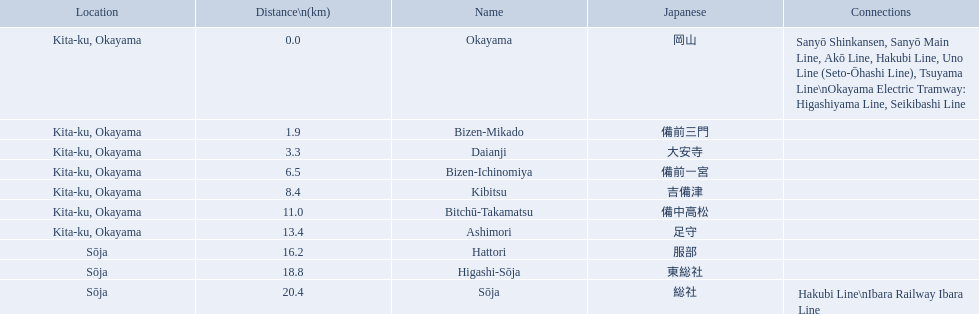What are all of the train names? Okayama, Bizen-Mikado, Daianji, Bizen-Ichinomiya, Kibitsu, Bitchū-Takamatsu, Ashimori, Hattori, Higashi-Sōja, Sōja. What is the distance for each? 0.0, 1.9, 3.3, 6.5, 8.4, 11.0, 13.4, 16.2, 18.8, 20.4. I'm looking to parse the entire table for insights. Could you assist me with that? {'header': ['Location', 'Distance\\n(km)', 'Name', 'Japanese', 'Connections'], 'rows': [['Kita-ku, Okayama', '0.0', 'Okayama', '岡山', 'Sanyō Shinkansen, Sanyō Main Line, Akō Line, Hakubi Line, Uno Line (Seto-Ōhashi Line), Tsuyama Line\\nOkayama Electric Tramway: Higashiyama Line, Seikibashi Line'], ['Kita-ku, Okayama', '1.9', 'Bizen-Mikado', '備前三門', ''], ['Kita-ku, Okayama', '3.3', 'Daianji', '大安寺', ''], ['Kita-ku, Okayama', '6.5', 'Bizen-Ichinomiya', '備前一宮', ''], ['Kita-ku, Okayama', '8.4', 'Kibitsu', '吉備津', ''], ['Kita-ku, Okayama', '11.0', 'Bitchū-Takamatsu', '備中高松', ''], ['Kita-ku, Okayama', '13.4', 'Ashimori', '足守', ''], ['Sōja', '16.2', 'Hattori', '服部', ''], ['Sōja', '18.8', 'Higashi-Sōja', '東総社', ''], ['Sōja', '20.4', 'Sōja', '総社', 'Hakubi Line\\nIbara Railway Ibara Line']]} And which train's distance is between 1 and 2 km? Bizen-Mikado. 